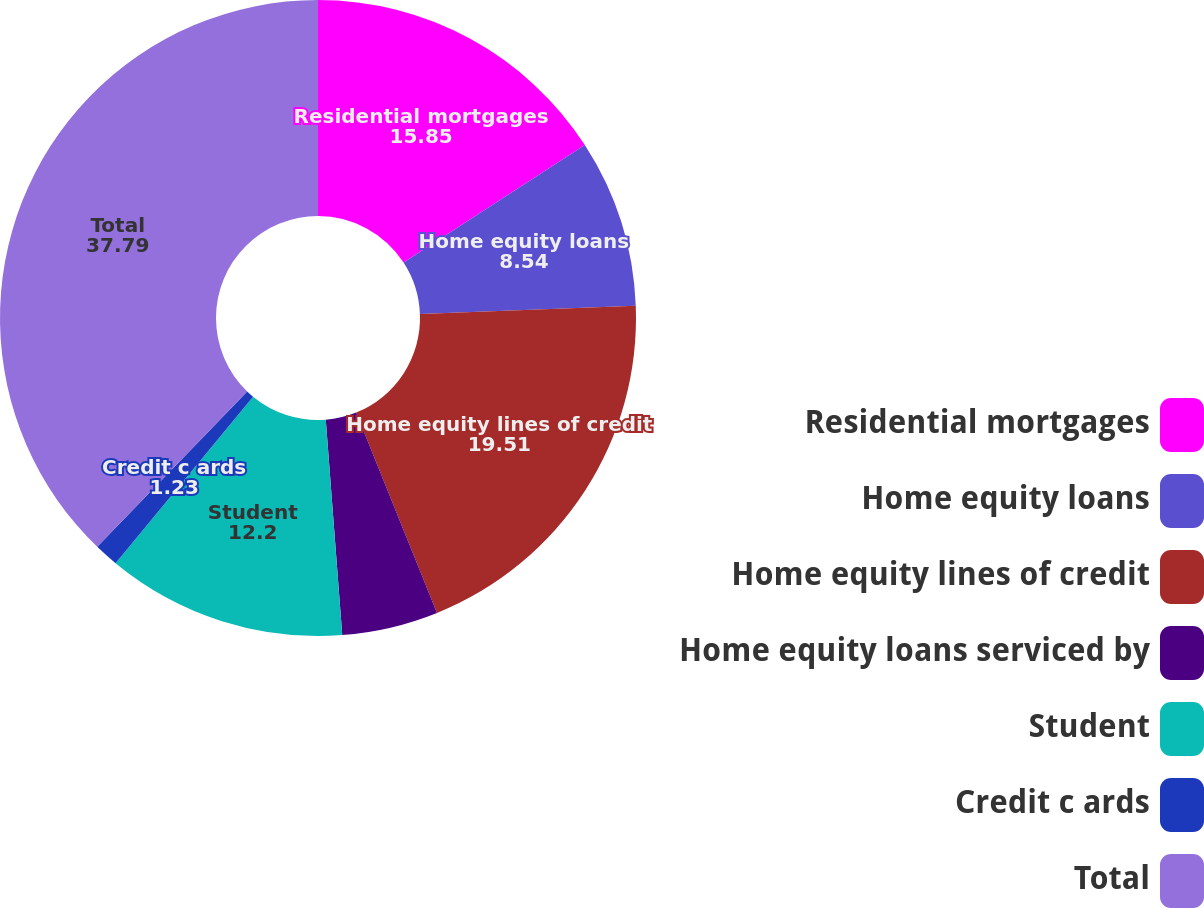Convert chart to OTSL. <chart><loc_0><loc_0><loc_500><loc_500><pie_chart><fcel>Residential mortgages<fcel>Home equity loans<fcel>Home equity lines of credit<fcel>Home equity loans serviced by<fcel>Student<fcel>Credit c ards<fcel>Total<nl><fcel>15.85%<fcel>8.54%<fcel>19.51%<fcel>4.89%<fcel>12.2%<fcel>1.23%<fcel>37.79%<nl></chart> 